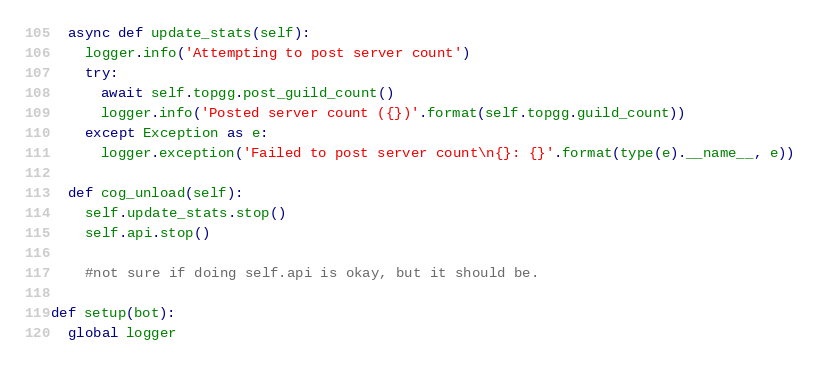<code> <loc_0><loc_0><loc_500><loc_500><_Python_>  async def update_stats(self):
    logger.info('Attempting to post server count')
    try:
      await self.topgg.post_guild_count()
      logger.info('Posted server count ({})'.format(self.topgg.guild_count))
    except Exception as e:
      logger.exception('Failed to post server count\n{}: {}'.format(type(e).__name__, e))

  def cog_unload(self):
    self.update_stats.stop()
    self.api.stop()
    
    #not sure if doing self.api is okay, but it should be.
  
def setup(bot):
  global logger</code> 